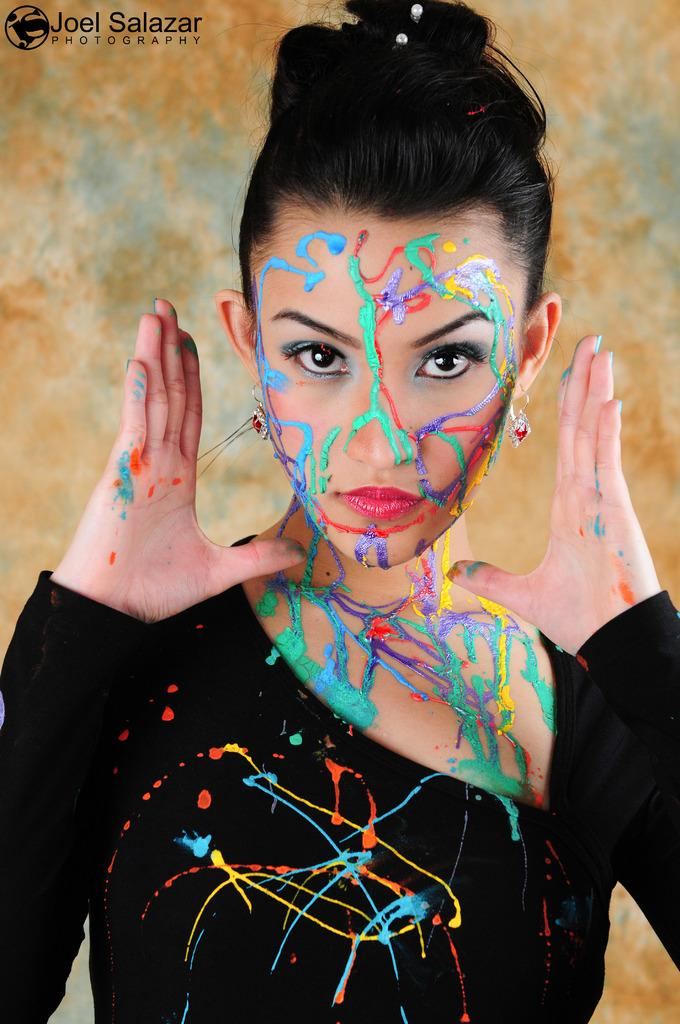Where was the image taken? The image is taken indoors. What can be seen in the middle of the image? There is a woman standing in the middle of the image. What is visible in the background of the image? There is a wall in the background of the image. What type of force is being applied to the copper in the image? There is no copper or force present in the image; it features a woman standing indoors with a wall in the background. What type of drink is the woman holding in the image? The image does not show the woman holding any drink. 